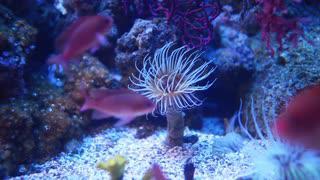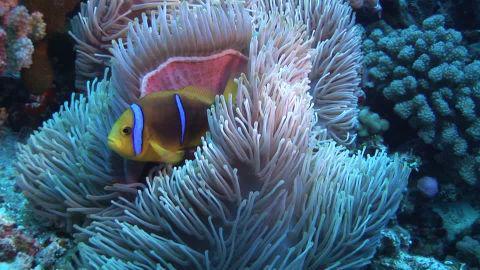The first image is the image on the left, the second image is the image on the right. Given the left and right images, does the statement "There are at least two fishes in the pair of images." hold true? Answer yes or no. Yes. 